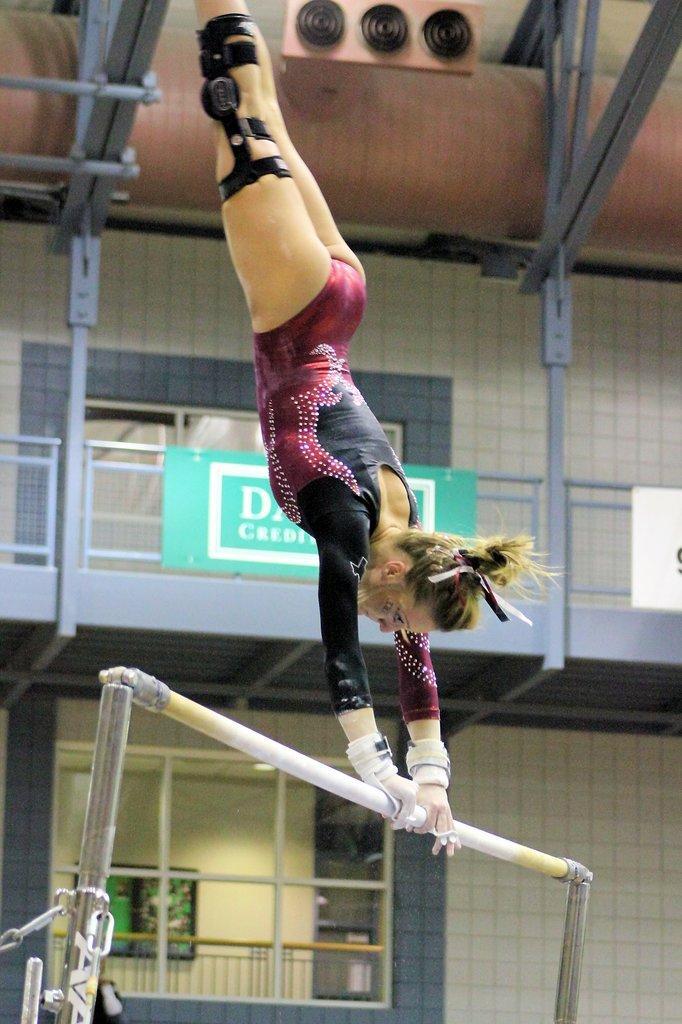Could you give a brief overview of what you see in this image? In this image I can see the person in the air. The person is wearing the red and black color dress. She is holding the rod. In the back there is a building and I can see the board and railing to the building. 